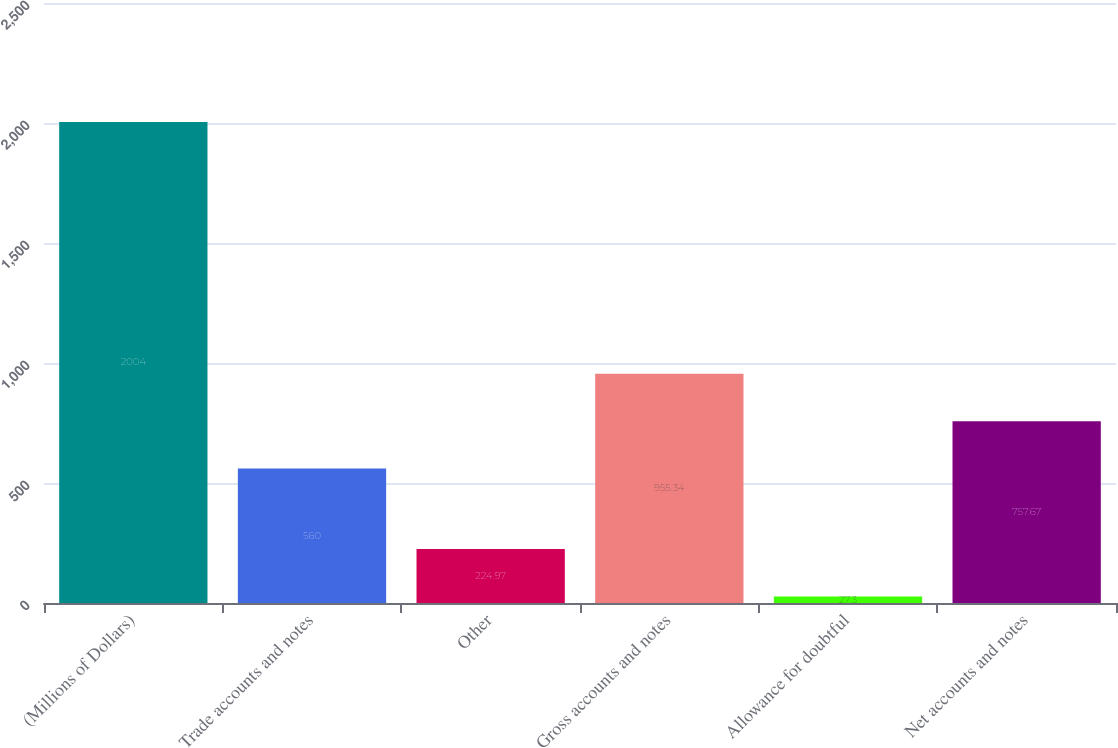<chart> <loc_0><loc_0><loc_500><loc_500><bar_chart><fcel>(Millions of Dollars)<fcel>Trade accounts and notes<fcel>Other<fcel>Gross accounts and notes<fcel>Allowance for doubtful<fcel>Net accounts and notes<nl><fcel>2004<fcel>560<fcel>224.97<fcel>955.34<fcel>27.3<fcel>757.67<nl></chart> 